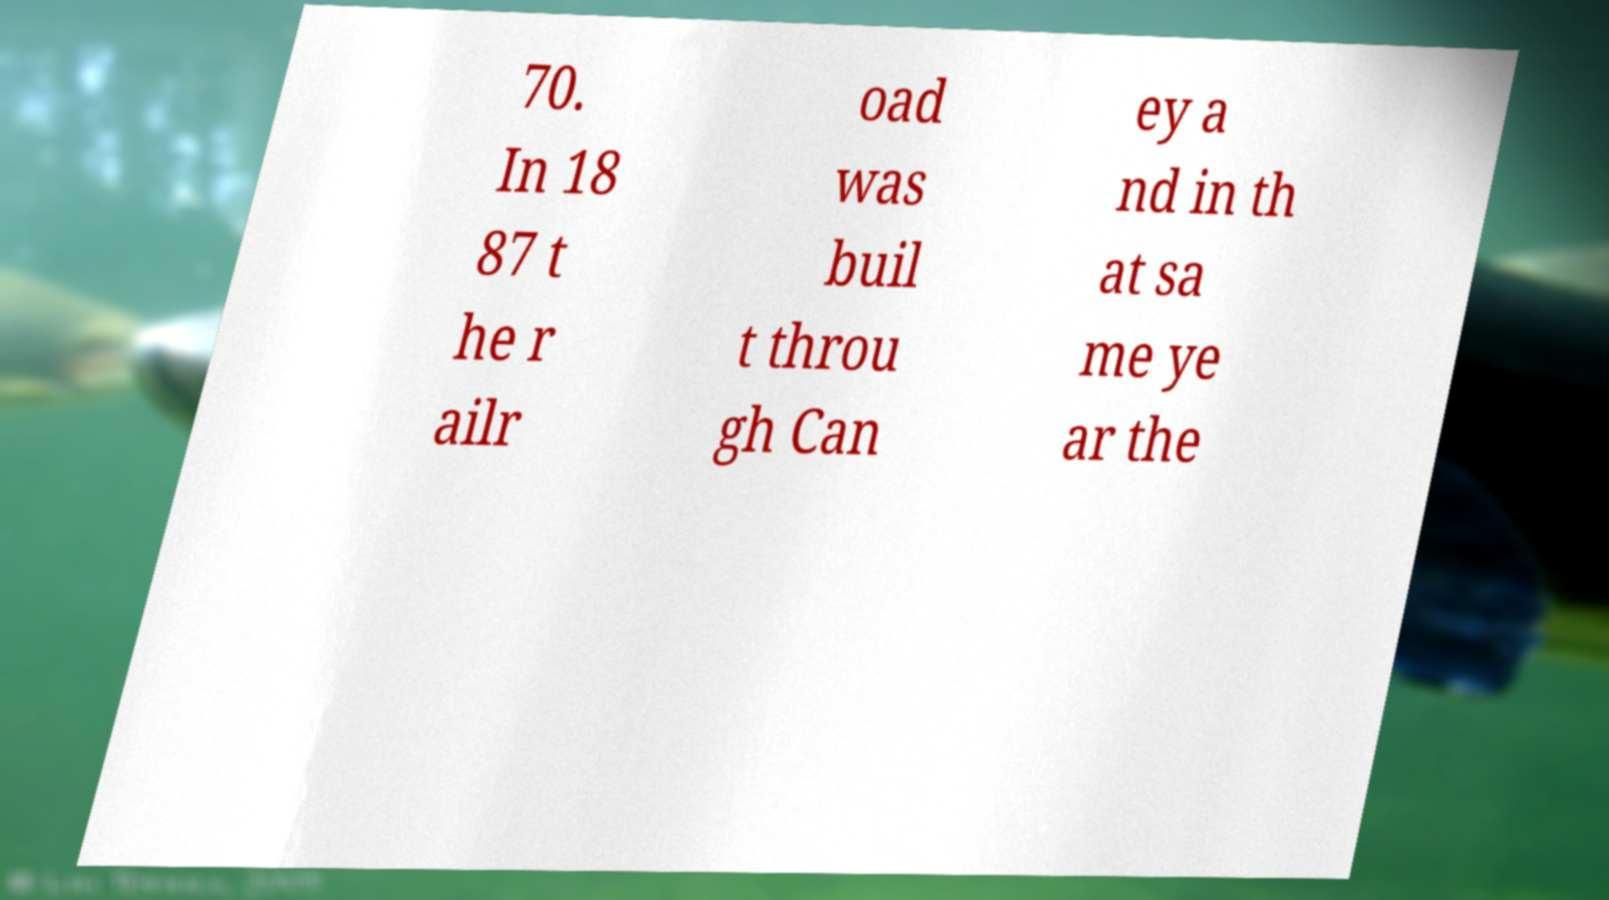For documentation purposes, I need the text within this image transcribed. Could you provide that? 70. In 18 87 t he r ailr oad was buil t throu gh Can ey a nd in th at sa me ye ar the 